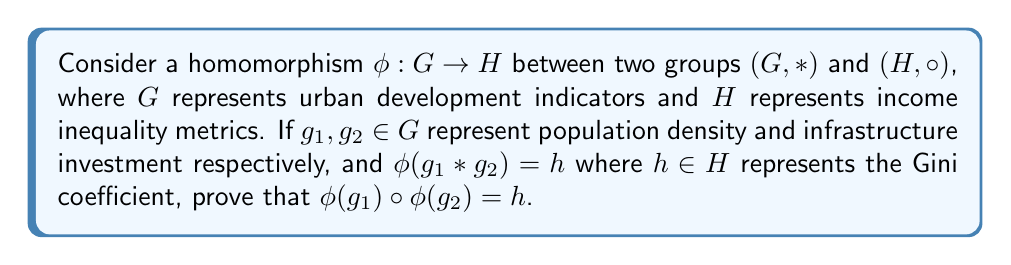Help me with this question. To prove that $\phi(g_1) \circ \phi(g_2) = h$, we'll use the properties of homomorphisms and the given information:

1) By definition, a homomorphism $\phi: G \to H$ preserves the group operation. This means that for any $a, b \in G$:

   $\phi(a * b) = \phi(a) \circ \phi(b)$

2) We're given that $\phi(g_1 * g_2) = h$

3) Applying the homomorphism property to $g_1$ and $g_2$:

   $\phi(g_1 * g_2) = \phi(g_1) \circ \phi(g_2)$

4) From steps 2 and 3, we can conclude:

   $h = \phi(g_1 * g_2) = \phi(g_1) \circ \phi(g_2)$

Therefore, we have proven that $\phi(g_1) \circ \phi(g_2) = h$.

This result demonstrates how the homomorphism preserves the relationship between urban development indicators (population density and infrastructure investment) and maps it to an income inequality metric (Gini coefficient) in a way that respects the group structures of both domains.
Answer: $\phi(g_1) \circ \phi(g_2) = h$ 